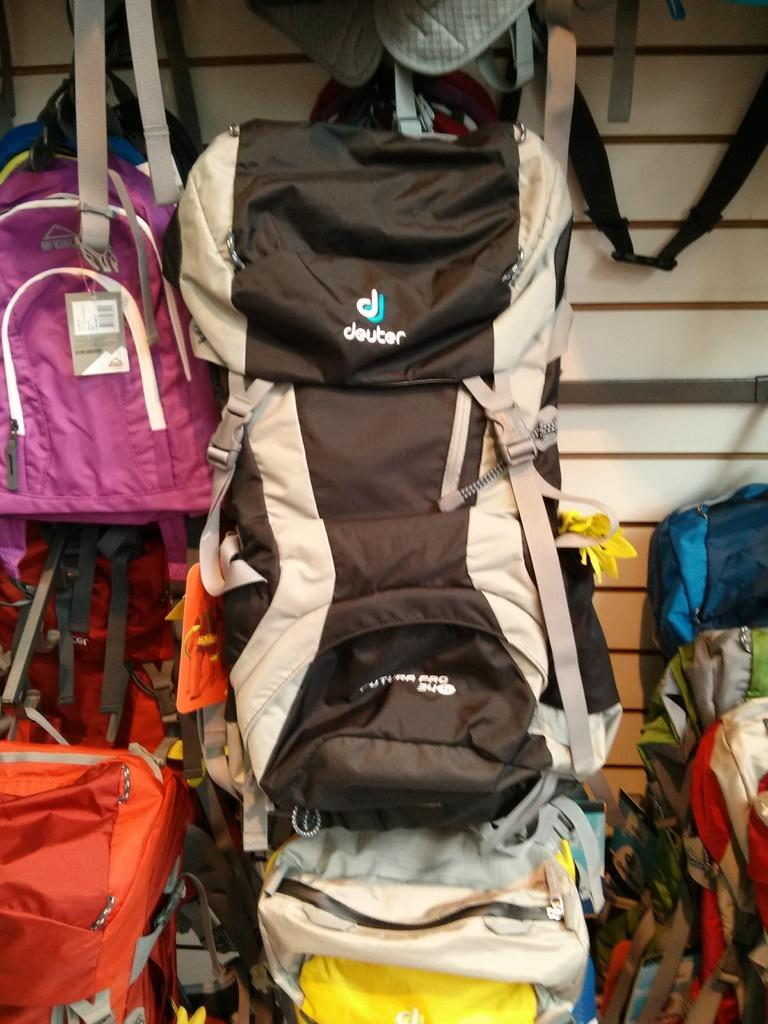<image>
Create a compact narrative representing the image presented. a Deuter backpack is hung up on display with others 